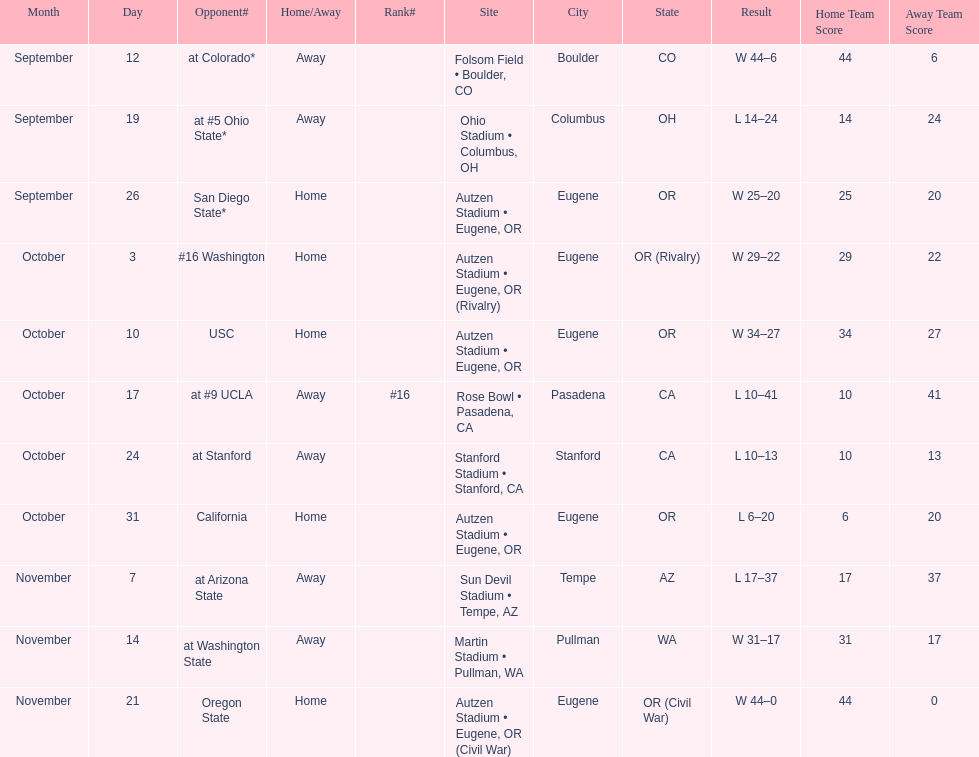Who was their last opponent of the season? Oregon State. 